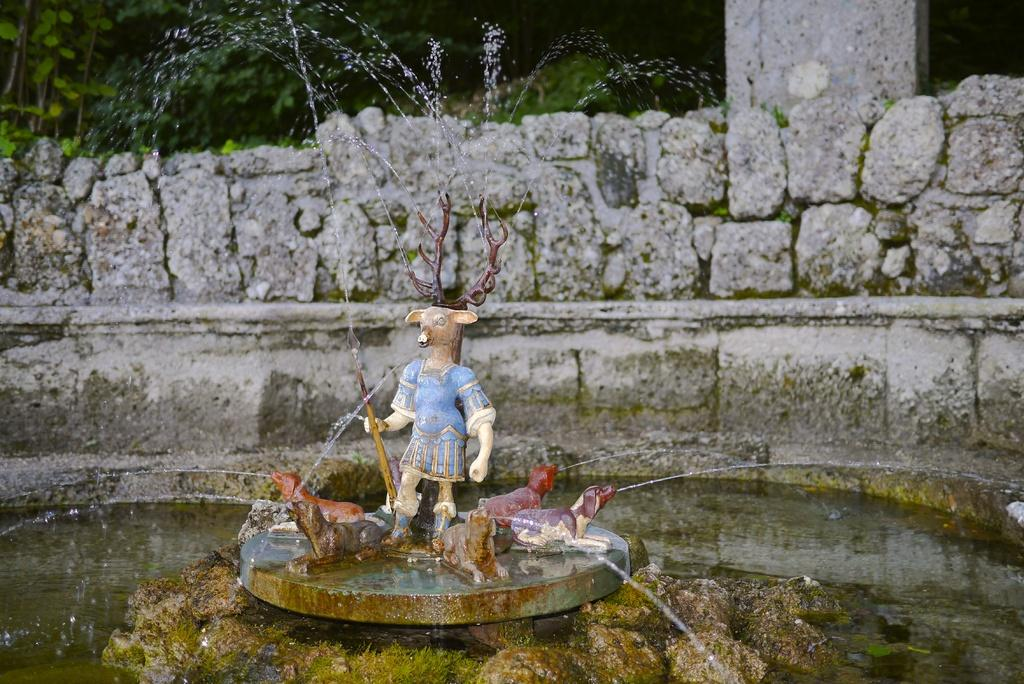What is the main subject in the image? There is a statue in the image. What other features can be seen in the image? There is a fountain in the image. What can be seen in the background of the image? There is a stone wall, a pillar, and greenery in the background of the image. What news is the queen discussing with her servant in the image? There is no queen or servant present in the image; it features a statue, a fountain, and a background with a stone wall, pillar, and greenery. 